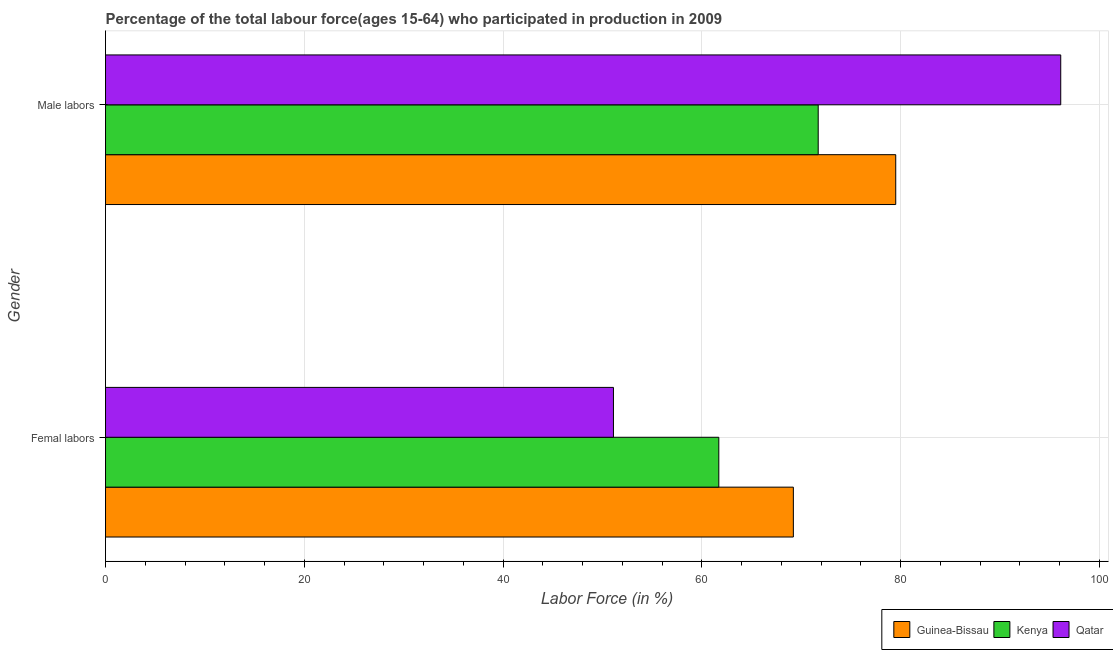How many bars are there on the 1st tick from the top?
Your answer should be very brief. 3. How many bars are there on the 1st tick from the bottom?
Your answer should be very brief. 3. What is the label of the 1st group of bars from the top?
Provide a succinct answer. Male labors. What is the percentage of female labor force in Kenya?
Offer a very short reply. 61.7. Across all countries, what is the maximum percentage of female labor force?
Make the answer very short. 69.2. Across all countries, what is the minimum percentage of male labour force?
Your answer should be compact. 71.7. In which country was the percentage of female labor force maximum?
Provide a succinct answer. Guinea-Bissau. In which country was the percentage of female labor force minimum?
Provide a succinct answer. Qatar. What is the total percentage of male labour force in the graph?
Your answer should be very brief. 247.3. What is the difference between the percentage of female labor force in Qatar and that in Guinea-Bissau?
Provide a short and direct response. -18.1. What is the difference between the percentage of female labor force in Qatar and the percentage of male labour force in Guinea-Bissau?
Your answer should be compact. -28.4. What is the average percentage of female labor force per country?
Offer a terse response. 60.67. What is the difference between the percentage of male labour force and percentage of female labor force in Guinea-Bissau?
Give a very brief answer. 10.3. What is the ratio of the percentage of male labour force in Qatar to that in Kenya?
Provide a short and direct response. 1.34. Is the percentage of male labour force in Qatar less than that in Kenya?
Make the answer very short. No. In how many countries, is the percentage of male labour force greater than the average percentage of male labour force taken over all countries?
Provide a succinct answer. 1. What does the 1st bar from the top in Male labors represents?
Your answer should be very brief. Qatar. What does the 2nd bar from the bottom in Femal labors represents?
Provide a succinct answer. Kenya. How many bars are there?
Offer a very short reply. 6. Are all the bars in the graph horizontal?
Provide a succinct answer. Yes. Does the graph contain any zero values?
Ensure brevity in your answer.  No. Where does the legend appear in the graph?
Your answer should be very brief. Bottom right. What is the title of the graph?
Your response must be concise. Percentage of the total labour force(ages 15-64) who participated in production in 2009. What is the label or title of the X-axis?
Your response must be concise. Labor Force (in %). What is the label or title of the Y-axis?
Ensure brevity in your answer.  Gender. What is the Labor Force (in %) of Guinea-Bissau in Femal labors?
Your response must be concise. 69.2. What is the Labor Force (in %) of Kenya in Femal labors?
Your response must be concise. 61.7. What is the Labor Force (in %) in Qatar in Femal labors?
Your answer should be very brief. 51.1. What is the Labor Force (in %) in Guinea-Bissau in Male labors?
Make the answer very short. 79.5. What is the Labor Force (in %) of Kenya in Male labors?
Ensure brevity in your answer.  71.7. What is the Labor Force (in %) of Qatar in Male labors?
Keep it short and to the point. 96.1. Across all Gender, what is the maximum Labor Force (in %) in Guinea-Bissau?
Provide a short and direct response. 79.5. Across all Gender, what is the maximum Labor Force (in %) in Kenya?
Your answer should be very brief. 71.7. Across all Gender, what is the maximum Labor Force (in %) of Qatar?
Keep it short and to the point. 96.1. Across all Gender, what is the minimum Labor Force (in %) of Guinea-Bissau?
Make the answer very short. 69.2. Across all Gender, what is the minimum Labor Force (in %) of Kenya?
Offer a very short reply. 61.7. Across all Gender, what is the minimum Labor Force (in %) in Qatar?
Make the answer very short. 51.1. What is the total Labor Force (in %) of Guinea-Bissau in the graph?
Your answer should be very brief. 148.7. What is the total Labor Force (in %) in Kenya in the graph?
Your response must be concise. 133.4. What is the total Labor Force (in %) of Qatar in the graph?
Provide a succinct answer. 147.2. What is the difference between the Labor Force (in %) in Qatar in Femal labors and that in Male labors?
Offer a terse response. -45. What is the difference between the Labor Force (in %) in Guinea-Bissau in Femal labors and the Labor Force (in %) in Kenya in Male labors?
Provide a short and direct response. -2.5. What is the difference between the Labor Force (in %) of Guinea-Bissau in Femal labors and the Labor Force (in %) of Qatar in Male labors?
Keep it short and to the point. -26.9. What is the difference between the Labor Force (in %) of Kenya in Femal labors and the Labor Force (in %) of Qatar in Male labors?
Keep it short and to the point. -34.4. What is the average Labor Force (in %) of Guinea-Bissau per Gender?
Your answer should be very brief. 74.35. What is the average Labor Force (in %) of Kenya per Gender?
Make the answer very short. 66.7. What is the average Labor Force (in %) in Qatar per Gender?
Your response must be concise. 73.6. What is the difference between the Labor Force (in %) of Guinea-Bissau and Labor Force (in %) of Qatar in Male labors?
Keep it short and to the point. -16.6. What is the difference between the Labor Force (in %) in Kenya and Labor Force (in %) in Qatar in Male labors?
Your answer should be very brief. -24.4. What is the ratio of the Labor Force (in %) of Guinea-Bissau in Femal labors to that in Male labors?
Give a very brief answer. 0.87. What is the ratio of the Labor Force (in %) of Kenya in Femal labors to that in Male labors?
Your answer should be compact. 0.86. What is the ratio of the Labor Force (in %) in Qatar in Femal labors to that in Male labors?
Your answer should be very brief. 0.53. What is the difference between the highest and the second highest Labor Force (in %) in Qatar?
Your answer should be compact. 45. What is the difference between the highest and the lowest Labor Force (in %) in Guinea-Bissau?
Your answer should be compact. 10.3. What is the difference between the highest and the lowest Labor Force (in %) in Qatar?
Your answer should be very brief. 45. 